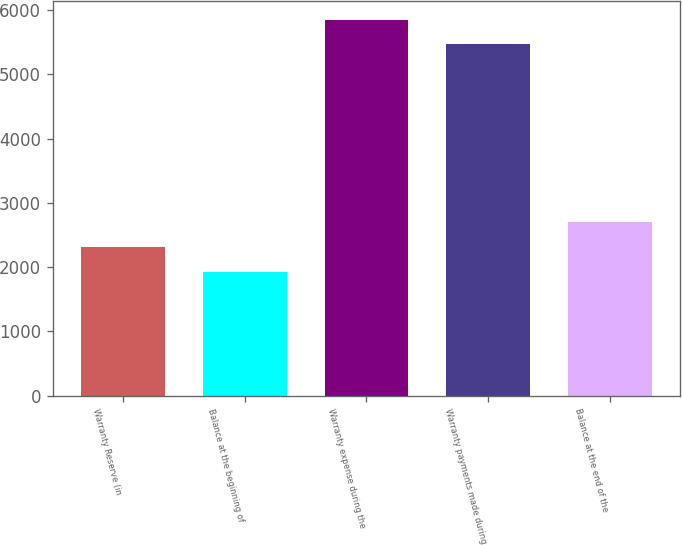Convert chart. <chart><loc_0><loc_0><loc_500><loc_500><bar_chart><fcel>Warranty Reserve (in<fcel>Balance at the beginning of<fcel>Warranty expense during the<fcel>Warranty payments made during<fcel>Balance at the end of the<nl><fcel>2309<fcel>1922<fcel>5851<fcel>5464<fcel>2696<nl></chart> 